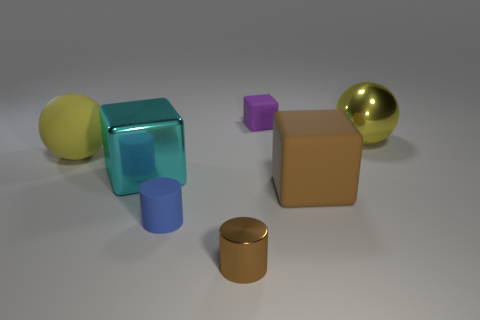There is a cyan metallic thing that is behind the blue thing; is there a big object that is left of it?
Make the answer very short. Yes. There is a blue rubber thing; is its shape the same as the brown thing that is to the left of the small purple rubber thing?
Keep it short and to the point. Yes. What number of other things are there of the same size as the blue matte object?
Provide a short and direct response. 2. How many blue things are metal blocks or rubber cylinders?
Your response must be concise. 1. What number of small things are in front of the big metal cube and right of the tiny rubber cylinder?
Make the answer very short. 1. There is a big yellow sphere to the right of the brown shiny cylinder in front of the big rubber thing that is to the left of the tiny purple block; what is its material?
Provide a short and direct response. Metal. What number of tiny brown things are the same material as the purple object?
Provide a short and direct response. 0. What is the shape of the thing that is the same color as the big rubber cube?
Keep it short and to the point. Cylinder. There is a purple thing that is the same size as the brown metal object; what is its shape?
Keep it short and to the point. Cube. What is the material of the block that is the same color as the small metal cylinder?
Provide a short and direct response. Rubber. 